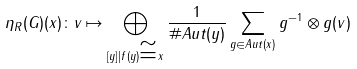Convert formula to latex. <formula><loc_0><loc_0><loc_500><loc_500>\eta _ { R } ( G ) ( x ) \colon v \mapsto \bigoplus _ { [ y ] | f ( y ) \cong x } \frac { 1 } { \# A u t ( y ) } \sum _ { g \in A u t ( x ) } g ^ { - 1 } \otimes g ( v )</formula> 